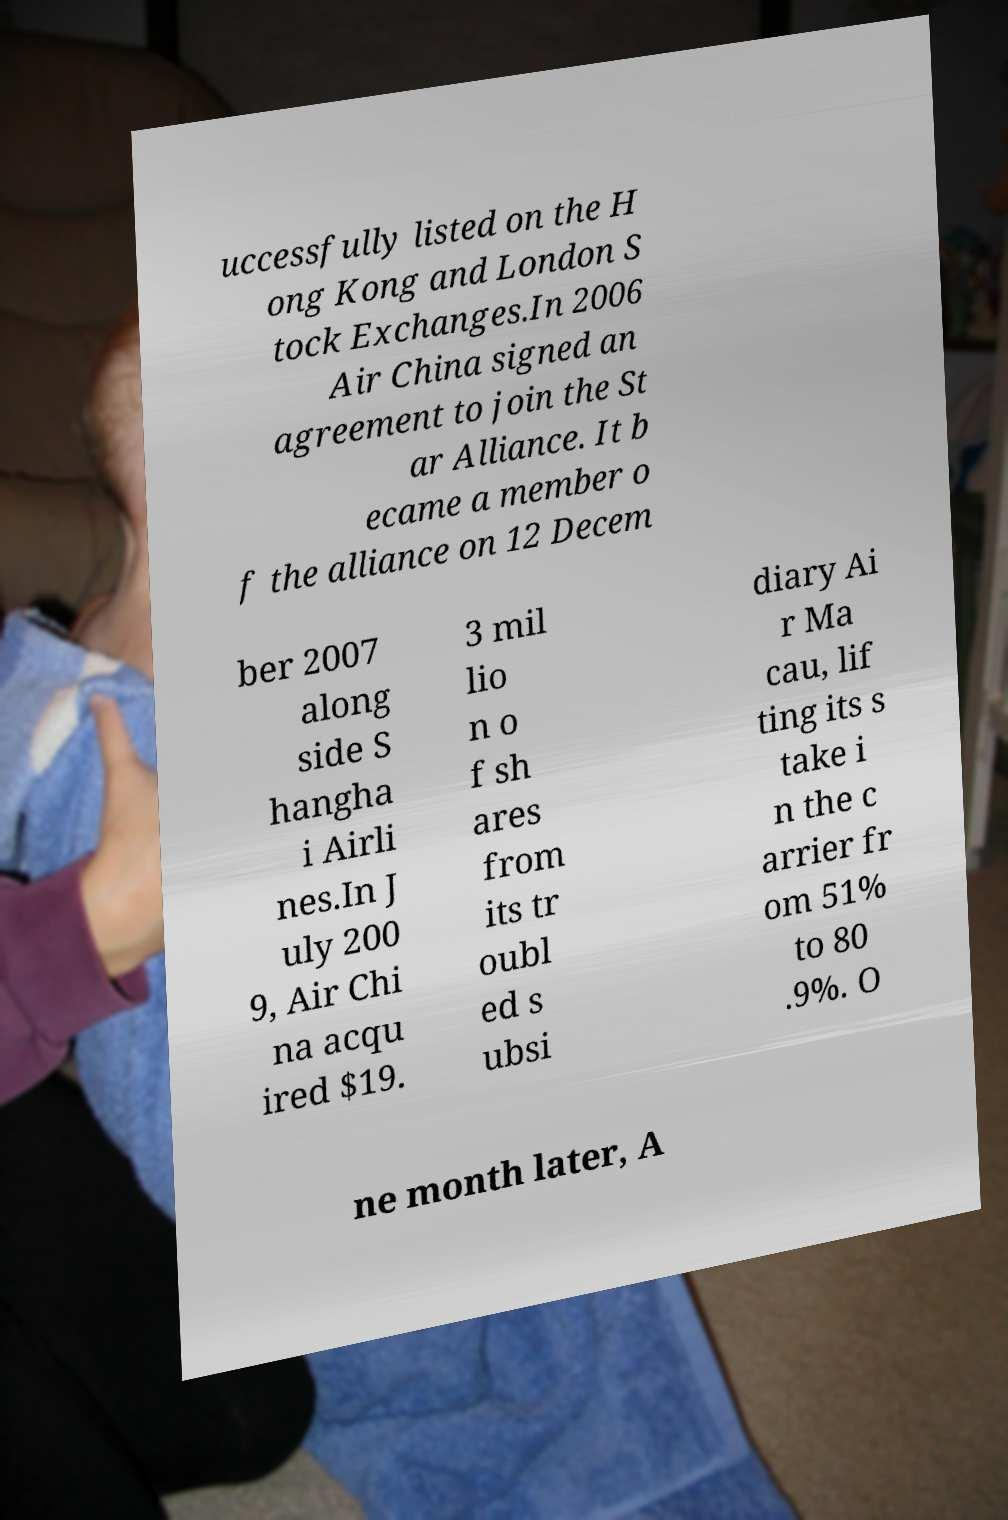Please read and relay the text visible in this image. What does it say? uccessfully listed on the H ong Kong and London S tock Exchanges.In 2006 Air China signed an agreement to join the St ar Alliance. It b ecame a member o f the alliance on 12 Decem ber 2007 along side S hangha i Airli nes.In J uly 200 9, Air Chi na acqu ired $19. 3 mil lio n o f sh ares from its tr oubl ed s ubsi diary Ai r Ma cau, lif ting its s take i n the c arrier fr om 51% to 80 .9%. O ne month later, A 